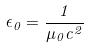Convert formula to latex. <formula><loc_0><loc_0><loc_500><loc_500>\epsilon _ { 0 } = \frac { 1 } { \mu _ { 0 } c ^ { 2 } }</formula> 